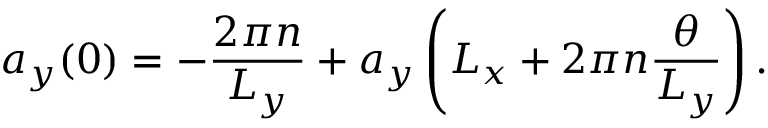<formula> <loc_0><loc_0><loc_500><loc_500>a _ { y } ( 0 ) = - \frac { 2 \pi n } { L _ { y } } + a _ { y } \left ( L _ { x } + 2 \pi n \frac { \theta } { L _ { y } } \right ) .</formula> 